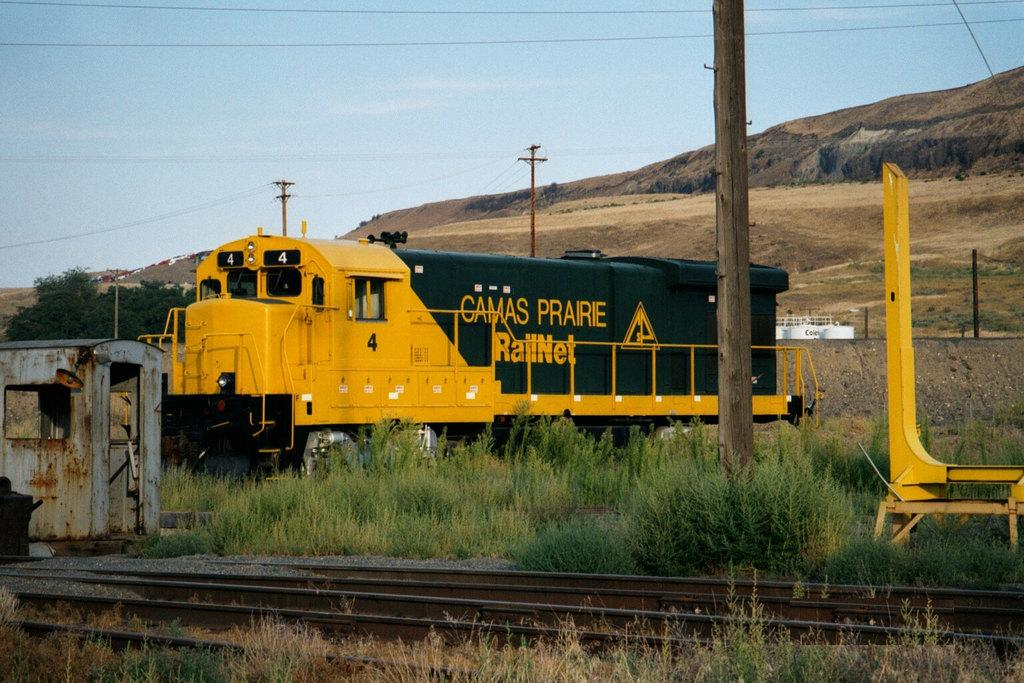<image>
Offer a succinct explanation of the picture presented. A yellow and black freight train with the Railnet logo on its side. 